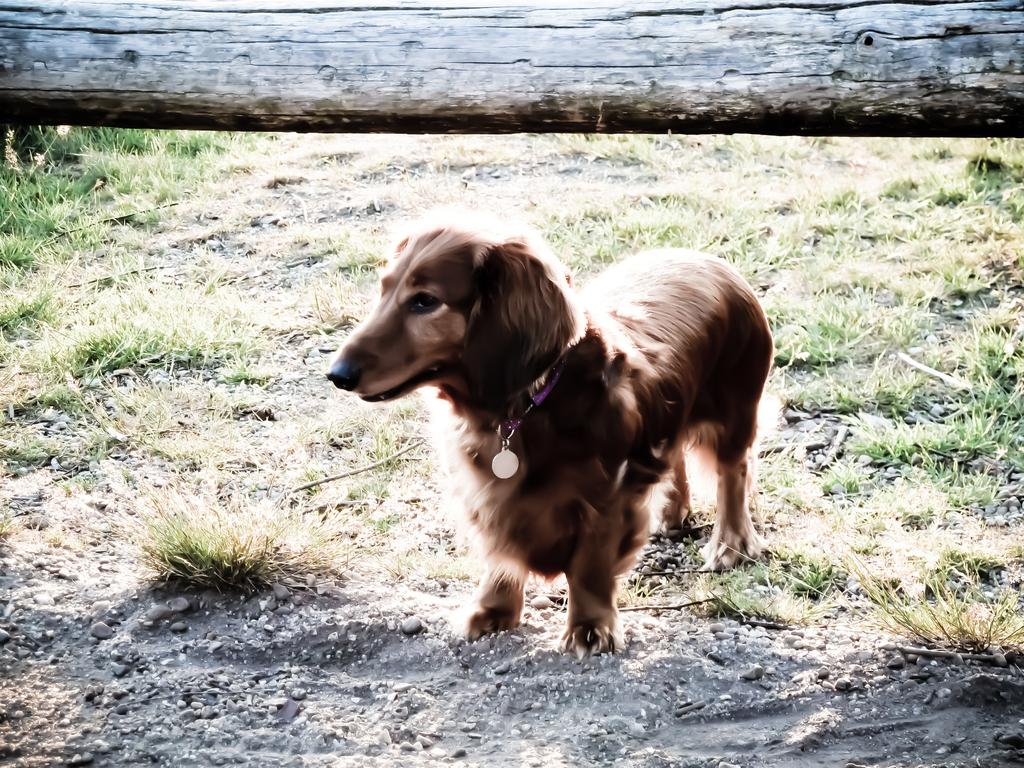What type of animal is in the image? There is a dog in the image. What color is the dog? The dog is brown in color. What is the surface that the dog is standing on? There is ground visible in the image, and green grass is present on the ground. What object can be seen at the top of the image? There is a wooden block at the top of the image. What type of bells can be heard ringing in the image? There are no bells present in the image, and therefore no sound can be heard. 